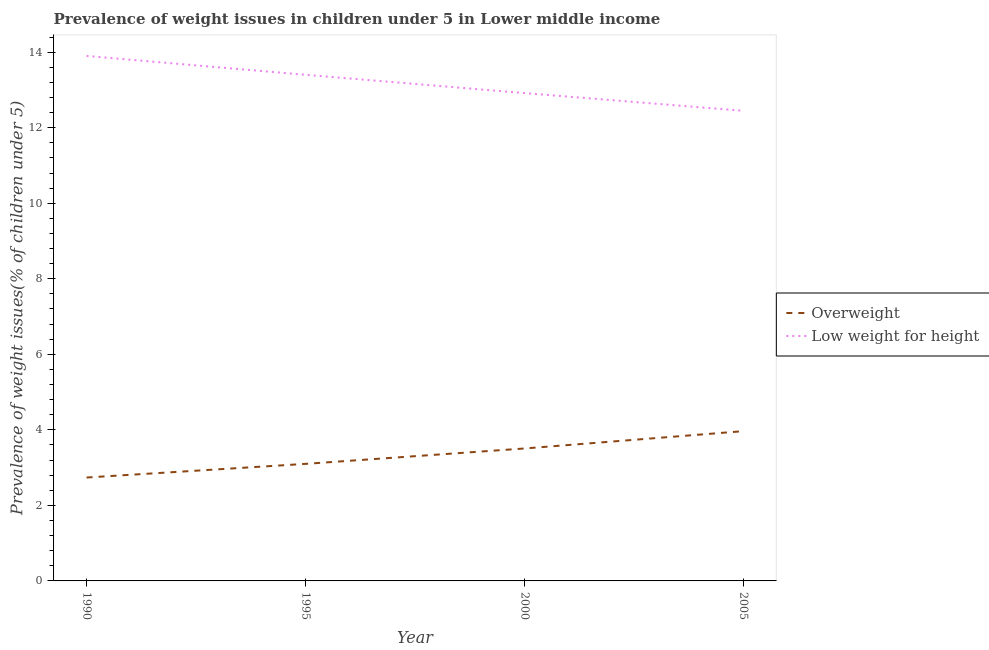How many different coloured lines are there?
Your answer should be very brief. 2. Does the line corresponding to percentage of underweight children intersect with the line corresponding to percentage of overweight children?
Your answer should be very brief. No. What is the percentage of underweight children in 1990?
Your response must be concise. 13.9. Across all years, what is the maximum percentage of overweight children?
Ensure brevity in your answer.  3.97. Across all years, what is the minimum percentage of overweight children?
Make the answer very short. 2.74. What is the total percentage of underweight children in the graph?
Keep it short and to the point. 52.66. What is the difference between the percentage of underweight children in 1995 and that in 2005?
Ensure brevity in your answer.  0.95. What is the difference between the percentage of overweight children in 1995 and the percentage of underweight children in 2000?
Your answer should be very brief. -9.82. What is the average percentage of underweight children per year?
Make the answer very short. 13.17. In the year 1995, what is the difference between the percentage of underweight children and percentage of overweight children?
Ensure brevity in your answer.  10.3. In how many years, is the percentage of underweight children greater than 12 %?
Provide a short and direct response. 4. What is the ratio of the percentage of underweight children in 1990 to that in 2000?
Make the answer very short. 1.08. Is the percentage of overweight children in 1995 less than that in 2005?
Your answer should be very brief. Yes. What is the difference between the highest and the second highest percentage of overweight children?
Provide a succinct answer. 0.46. What is the difference between the highest and the lowest percentage of overweight children?
Keep it short and to the point. 1.23. Is the sum of the percentage of underweight children in 1995 and 2005 greater than the maximum percentage of overweight children across all years?
Give a very brief answer. Yes. Does the percentage of underweight children monotonically increase over the years?
Your answer should be compact. No. How many lines are there?
Your answer should be compact. 2. Are the values on the major ticks of Y-axis written in scientific E-notation?
Offer a terse response. No. Does the graph contain any zero values?
Give a very brief answer. No. Where does the legend appear in the graph?
Keep it short and to the point. Center right. What is the title of the graph?
Your answer should be compact. Prevalence of weight issues in children under 5 in Lower middle income. What is the label or title of the Y-axis?
Ensure brevity in your answer.  Prevalence of weight issues(% of children under 5). What is the Prevalence of weight issues(% of children under 5) of Overweight in 1990?
Provide a short and direct response. 2.74. What is the Prevalence of weight issues(% of children under 5) in Low weight for height in 1990?
Give a very brief answer. 13.9. What is the Prevalence of weight issues(% of children under 5) in Overweight in 1995?
Provide a short and direct response. 3.1. What is the Prevalence of weight issues(% of children under 5) in Low weight for height in 1995?
Your answer should be compact. 13.4. What is the Prevalence of weight issues(% of children under 5) of Overweight in 2000?
Keep it short and to the point. 3.51. What is the Prevalence of weight issues(% of children under 5) in Low weight for height in 2000?
Your answer should be very brief. 12.92. What is the Prevalence of weight issues(% of children under 5) of Overweight in 2005?
Provide a succinct answer. 3.97. What is the Prevalence of weight issues(% of children under 5) in Low weight for height in 2005?
Offer a very short reply. 12.45. Across all years, what is the maximum Prevalence of weight issues(% of children under 5) in Overweight?
Give a very brief answer. 3.97. Across all years, what is the maximum Prevalence of weight issues(% of children under 5) of Low weight for height?
Provide a succinct answer. 13.9. Across all years, what is the minimum Prevalence of weight issues(% of children under 5) of Overweight?
Provide a short and direct response. 2.74. Across all years, what is the minimum Prevalence of weight issues(% of children under 5) of Low weight for height?
Keep it short and to the point. 12.45. What is the total Prevalence of weight issues(% of children under 5) in Overweight in the graph?
Offer a terse response. 13.31. What is the total Prevalence of weight issues(% of children under 5) in Low weight for height in the graph?
Your answer should be very brief. 52.66. What is the difference between the Prevalence of weight issues(% of children under 5) in Overweight in 1990 and that in 1995?
Your answer should be very brief. -0.36. What is the difference between the Prevalence of weight issues(% of children under 5) in Low weight for height in 1990 and that in 1995?
Offer a very short reply. 0.5. What is the difference between the Prevalence of weight issues(% of children under 5) in Overweight in 1990 and that in 2000?
Give a very brief answer. -0.77. What is the difference between the Prevalence of weight issues(% of children under 5) of Low weight for height in 1990 and that in 2000?
Your response must be concise. 0.98. What is the difference between the Prevalence of weight issues(% of children under 5) of Overweight in 1990 and that in 2005?
Your answer should be compact. -1.23. What is the difference between the Prevalence of weight issues(% of children under 5) in Low weight for height in 1990 and that in 2005?
Your answer should be compact. 1.45. What is the difference between the Prevalence of weight issues(% of children under 5) of Overweight in 1995 and that in 2000?
Your response must be concise. -0.41. What is the difference between the Prevalence of weight issues(% of children under 5) in Low weight for height in 1995 and that in 2000?
Your answer should be very brief. 0.48. What is the difference between the Prevalence of weight issues(% of children under 5) in Overweight in 1995 and that in 2005?
Make the answer very short. -0.87. What is the difference between the Prevalence of weight issues(% of children under 5) of Low weight for height in 1995 and that in 2005?
Offer a terse response. 0.95. What is the difference between the Prevalence of weight issues(% of children under 5) in Overweight in 2000 and that in 2005?
Offer a terse response. -0.46. What is the difference between the Prevalence of weight issues(% of children under 5) in Low weight for height in 2000 and that in 2005?
Your answer should be very brief. 0.47. What is the difference between the Prevalence of weight issues(% of children under 5) of Overweight in 1990 and the Prevalence of weight issues(% of children under 5) of Low weight for height in 1995?
Give a very brief answer. -10.66. What is the difference between the Prevalence of weight issues(% of children under 5) of Overweight in 1990 and the Prevalence of weight issues(% of children under 5) of Low weight for height in 2000?
Give a very brief answer. -10.18. What is the difference between the Prevalence of weight issues(% of children under 5) of Overweight in 1990 and the Prevalence of weight issues(% of children under 5) of Low weight for height in 2005?
Ensure brevity in your answer.  -9.71. What is the difference between the Prevalence of weight issues(% of children under 5) of Overweight in 1995 and the Prevalence of weight issues(% of children under 5) of Low weight for height in 2000?
Your response must be concise. -9.82. What is the difference between the Prevalence of weight issues(% of children under 5) in Overweight in 1995 and the Prevalence of weight issues(% of children under 5) in Low weight for height in 2005?
Keep it short and to the point. -9.35. What is the difference between the Prevalence of weight issues(% of children under 5) of Overweight in 2000 and the Prevalence of weight issues(% of children under 5) of Low weight for height in 2005?
Your response must be concise. -8.94. What is the average Prevalence of weight issues(% of children under 5) in Overweight per year?
Ensure brevity in your answer.  3.33. What is the average Prevalence of weight issues(% of children under 5) of Low weight for height per year?
Offer a very short reply. 13.17. In the year 1990, what is the difference between the Prevalence of weight issues(% of children under 5) in Overweight and Prevalence of weight issues(% of children under 5) in Low weight for height?
Your answer should be compact. -11.16. In the year 1995, what is the difference between the Prevalence of weight issues(% of children under 5) in Overweight and Prevalence of weight issues(% of children under 5) in Low weight for height?
Offer a terse response. -10.3. In the year 2000, what is the difference between the Prevalence of weight issues(% of children under 5) in Overweight and Prevalence of weight issues(% of children under 5) in Low weight for height?
Your answer should be very brief. -9.41. In the year 2005, what is the difference between the Prevalence of weight issues(% of children under 5) in Overweight and Prevalence of weight issues(% of children under 5) in Low weight for height?
Your response must be concise. -8.48. What is the ratio of the Prevalence of weight issues(% of children under 5) in Overweight in 1990 to that in 1995?
Give a very brief answer. 0.88. What is the ratio of the Prevalence of weight issues(% of children under 5) in Low weight for height in 1990 to that in 1995?
Make the answer very short. 1.04. What is the ratio of the Prevalence of weight issues(% of children under 5) in Overweight in 1990 to that in 2000?
Your response must be concise. 0.78. What is the ratio of the Prevalence of weight issues(% of children under 5) of Low weight for height in 1990 to that in 2000?
Your answer should be compact. 1.08. What is the ratio of the Prevalence of weight issues(% of children under 5) of Overweight in 1990 to that in 2005?
Provide a succinct answer. 0.69. What is the ratio of the Prevalence of weight issues(% of children under 5) in Low weight for height in 1990 to that in 2005?
Keep it short and to the point. 1.12. What is the ratio of the Prevalence of weight issues(% of children under 5) in Overweight in 1995 to that in 2000?
Offer a terse response. 0.88. What is the ratio of the Prevalence of weight issues(% of children under 5) in Low weight for height in 1995 to that in 2000?
Offer a terse response. 1.04. What is the ratio of the Prevalence of weight issues(% of children under 5) in Overweight in 1995 to that in 2005?
Provide a succinct answer. 0.78. What is the ratio of the Prevalence of weight issues(% of children under 5) of Low weight for height in 1995 to that in 2005?
Your answer should be compact. 1.08. What is the ratio of the Prevalence of weight issues(% of children under 5) in Overweight in 2000 to that in 2005?
Offer a very short reply. 0.88. What is the ratio of the Prevalence of weight issues(% of children under 5) in Low weight for height in 2000 to that in 2005?
Your answer should be compact. 1.04. What is the difference between the highest and the second highest Prevalence of weight issues(% of children under 5) in Overweight?
Offer a very short reply. 0.46. What is the difference between the highest and the second highest Prevalence of weight issues(% of children under 5) in Low weight for height?
Ensure brevity in your answer.  0.5. What is the difference between the highest and the lowest Prevalence of weight issues(% of children under 5) in Overweight?
Give a very brief answer. 1.23. What is the difference between the highest and the lowest Prevalence of weight issues(% of children under 5) in Low weight for height?
Give a very brief answer. 1.45. 